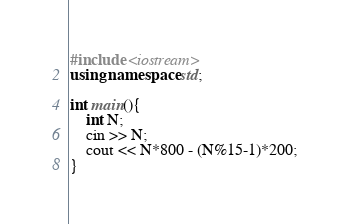Convert code to text. <code><loc_0><loc_0><loc_500><loc_500><_C++_>#include <iostream>
using namespace std;

int main(){
	int N;
	cin >> N;
	cout << N*800 - (N%15-1)*200;
}</code> 